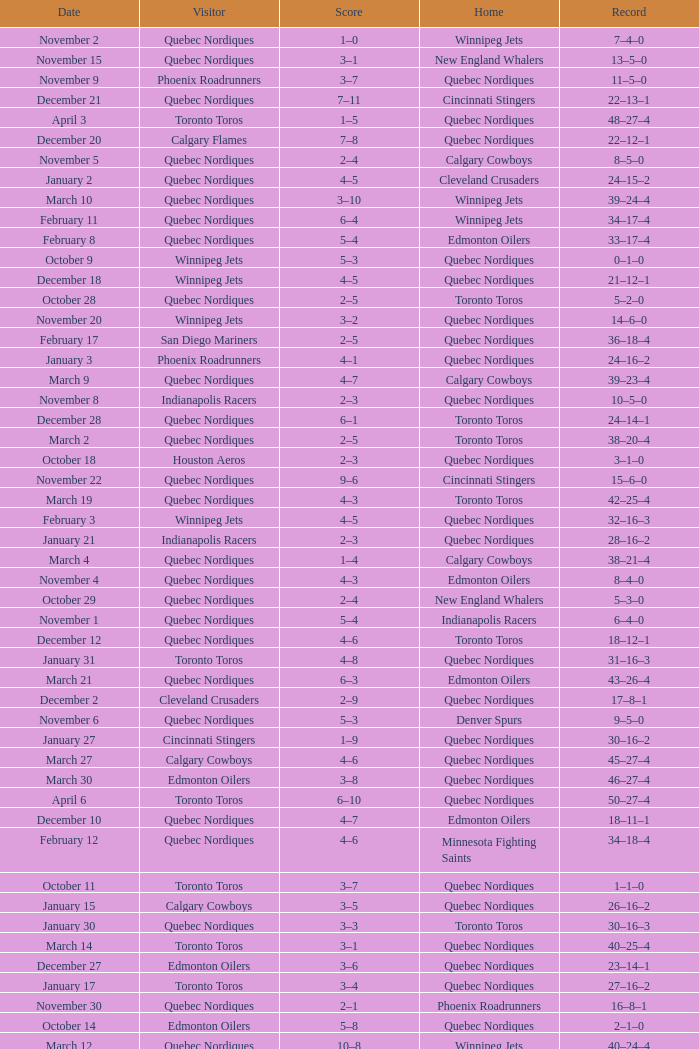What was the date of the game with a score of 2–1? November 30. 